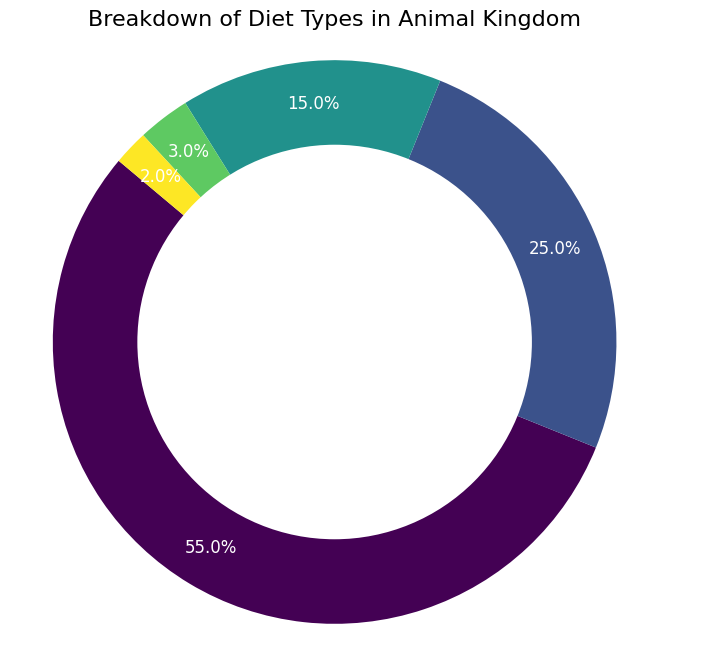What's the most common diet type in the animal kingdom? The pie chart shows that herbivores occupy the largest portion of the chart at 55%. Therefore, the most common diet type is herbivores.
Answer: Herbivores What percentage of animals are carnivores? According to the pie chart, the segment for carnivores is labeled as 25%, indicating that 25% of animals are carnivores.
Answer: 25% How much smaller is the percentage of insectivores compared to herbivores? From the pie chart, herbivores are 55% and insectivores are 2%. By subtracting the percentage of insectivores from herbivores (55% - 2%), you find that the percentage of insectivores is 53% smaller.
Answer: 53% Which diet type is more common, omnivores or detritivores? By examining the pie chart, omnivores have a segment labeled 15% and detritivores have a segment labeled 3%. Therefore, omnivores are more common than detritivores.
Answer: Omnivores What is the total percentage of animals that are either herbivores or carnivores? To find the total percentage of herbivores and carnivores, add their percentages together. Herbivores are 55% and carnivores are 25%. So, 55% + 25% = 80%.
Answer: 80% What color represents omnivores? By looking at the specific color labels in the pie chart, omnivores are represented by a unique color. Identify the color which corresponds to the 15% segment labeled omnivores.
Answer: Depends on the color that corresponds to the 15% segment labeled omnivores in the pie chart (e.g., green, blue, etc.) Are herbivores more than twice as common as carnivores? Comparing herbivores at 55% and carnivores at 25%, double the percentage of carnivores is 25% * 2 = 50%. Since 55% > 50%, herbivores are indeed more than twice as common as carnivores.
Answer: Yes What is the difference in percentage between omnivores and detritivores? From the pie chart, omnivores are 15% and detritivores are 3%. Subtract the smaller percentage from the larger one: 15% - 3% = 12%.
Answer: 12% What fraction of the animal kingdom is represented by insectivores? In the pie chart, insectivores are labeled as 2%. This percentage can be converted to a fraction: 2/100 or simplified, 1/50.
Answer: 1/50 